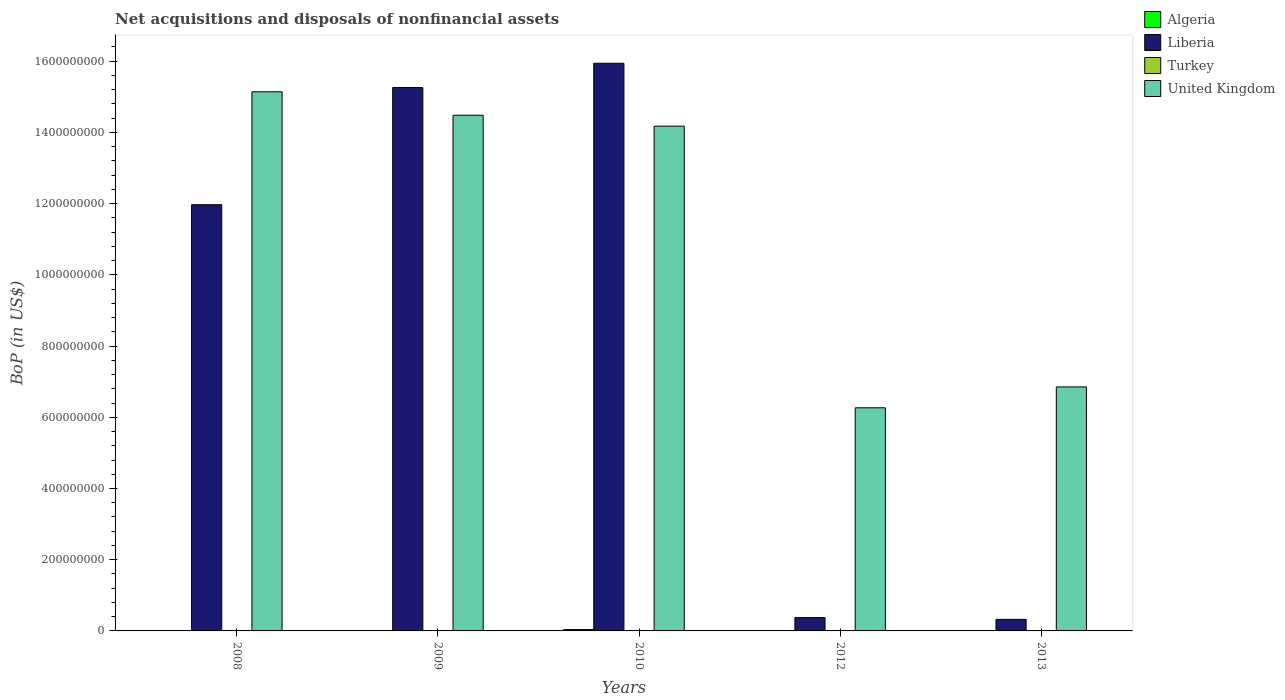How many groups of bars are there?
Offer a very short reply. 5. Are the number of bars on each tick of the X-axis equal?
Provide a succinct answer. No. How many bars are there on the 1st tick from the left?
Ensure brevity in your answer.  2. How many bars are there on the 2nd tick from the right?
Make the answer very short. 2. In how many cases, is the number of bars for a given year not equal to the number of legend labels?
Your answer should be compact. 5. What is the Balance of Payments in Liberia in 2012?
Ensure brevity in your answer.  3.74e+07. Across all years, what is the maximum Balance of Payments in United Kingdom?
Your response must be concise. 1.51e+09. Across all years, what is the minimum Balance of Payments in Turkey?
Make the answer very short. 0. What is the total Balance of Payments in Algeria in the graph?
Ensure brevity in your answer.  4.05e+06. What is the difference between the Balance of Payments in United Kingdom in 2010 and that in 2013?
Your answer should be very brief. 7.32e+08. What is the difference between the Balance of Payments in Liberia in 2008 and the Balance of Payments in United Kingdom in 2010?
Provide a short and direct response. -2.21e+08. What is the average Balance of Payments in United Kingdom per year?
Your answer should be very brief. 1.14e+09. In the year 2010, what is the difference between the Balance of Payments in Algeria and Balance of Payments in United Kingdom?
Your answer should be very brief. -1.41e+09. In how many years, is the Balance of Payments in Liberia greater than 800000000 US$?
Ensure brevity in your answer.  3. What is the ratio of the Balance of Payments in United Kingdom in 2010 to that in 2013?
Offer a terse response. 2.07. Is the Balance of Payments in Liberia in 2008 less than that in 2010?
Make the answer very short. Yes. What is the difference between the highest and the second highest Balance of Payments in Liberia?
Your answer should be compact. 6.83e+07. What is the difference between the highest and the lowest Balance of Payments in United Kingdom?
Provide a succinct answer. 8.87e+08. Is the sum of the Balance of Payments in Liberia in 2009 and 2013 greater than the maximum Balance of Payments in Turkey across all years?
Give a very brief answer. Yes. Is it the case that in every year, the sum of the Balance of Payments in Turkey and Balance of Payments in Algeria is greater than the Balance of Payments in Liberia?
Provide a succinct answer. No. Are all the bars in the graph horizontal?
Give a very brief answer. No. How many years are there in the graph?
Give a very brief answer. 5. What is the difference between two consecutive major ticks on the Y-axis?
Offer a terse response. 2.00e+08. Does the graph contain any zero values?
Your answer should be very brief. Yes. How are the legend labels stacked?
Offer a very short reply. Vertical. What is the title of the graph?
Keep it short and to the point. Net acquisitions and disposals of nonfinancial assets. What is the label or title of the X-axis?
Provide a succinct answer. Years. What is the label or title of the Y-axis?
Your response must be concise. BoP (in US$). What is the BoP (in US$) of Liberia in 2008?
Offer a terse response. 1.20e+09. What is the BoP (in US$) of United Kingdom in 2008?
Provide a short and direct response. 1.51e+09. What is the BoP (in US$) in Liberia in 2009?
Ensure brevity in your answer.  1.53e+09. What is the BoP (in US$) of United Kingdom in 2009?
Offer a terse response. 1.45e+09. What is the BoP (in US$) in Algeria in 2010?
Provide a short and direct response. 3.82e+06. What is the BoP (in US$) in Liberia in 2010?
Offer a very short reply. 1.59e+09. What is the BoP (in US$) of Turkey in 2010?
Your answer should be very brief. 0. What is the BoP (in US$) in United Kingdom in 2010?
Your answer should be compact. 1.42e+09. What is the BoP (in US$) of Algeria in 2012?
Your answer should be very brief. 0. What is the BoP (in US$) in Liberia in 2012?
Your response must be concise. 3.74e+07. What is the BoP (in US$) in Turkey in 2012?
Your response must be concise. 0. What is the BoP (in US$) of United Kingdom in 2012?
Provide a short and direct response. 6.27e+08. What is the BoP (in US$) in Algeria in 2013?
Give a very brief answer. 2.24e+05. What is the BoP (in US$) of Liberia in 2013?
Give a very brief answer. 3.25e+07. What is the BoP (in US$) in United Kingdom in 2013?
Keep it short and to the point. 6.85e+08. Across all years, what is the maximum BoP (in US$) of Algeria?
Provide a short and direct response. 3.82e+06. Across all years, what is the maximum BoP (in US$) in Liberia?
Provide a succinct answer. 1.59e+09. Across all years, what is the maximum BoP (in US$) in United Kingdom?
Offer a very short reply. 1.51e+09. Across all years, what is the minimum BoP (in US$) in Liberia?
Offer a very short reply. 3.25e+07. Across all years, what is the minimum BoP (in US$) of United Kingdom?
Keep it short and to the point. 6.27e+08. What is the total BoP (in US$) of Algeria in the graph?
Give a very brief answer. 4.05e+06. What is the total BoP (in US$) in Liberia in the graph?
Your response must be concise. 4.39e+09. What is the total BoP (in US$) of United Kingdom in the graph?
Offer a very short reply. 5.69e+09. What is the difference between the BoP (in US$) of Liberia in 2008 and that in 2009?
Your answer should be compact. -3.29e+08. What is the difference between the BoP (in US$) of United Kingdom in 2008 and that in 2009?
Provide a succinct answer. 6.58e+07. What is the difference between the BoP (in US$) of Liberia in 2008 and that in 2010?
Provide a succinct answer. -3.97e+08. What is the difference between the BoP (in US$) of United Kingdom in 2008 and that in 2010?
Ensure brevity in your answer.  9.65e+07. What is the difference between the BoP (in US$) of Liberia in 2008 and that in 2012?
Offer a terse response. 1.16e+09. What is the difference between the BoP (in US$) in United Kingdom in 2008 and that in 2012?
Your answer should be compact. 8.87e+08. What is the difference between the BoP (in US$) of Liberia in 2008 and that in 2013?
Offer a very short reply. 1.16e+09. What is the difference between the BoP (in US$) of United Kingdom in 2008 and that in 2013?
Offer a very short reply. 8.29e+08. What is the difference between the BoP (in US$) of Liberia in 2009 and that in 2010?
Provide a succinct answer. -6.83e+07. What is the difference between the BoP (in US$) in United Kingdom in 2009 and that in 2010?
Keep it short and to the point. 3.08e+07. What is the difference between the BoP (in US$) of Liberia in 2009 and that in 2012?
Ensure brevity in your answer.  1.49e+09. What is the difference between the BoP (in US$) in United Kingdom in 2009 and that in 2012?
Provide a short and direct response. 8.22e+08. What is the difference between the BoP (in US$) of Liberia in 2009 and that in 2013?
Your response must be concise. 1.49e+09. What is the difference between the BoP (in US$) in United Kingdom in 2009 and that in 2013?
Your answer should be very brief. 7.63e+08. What is the difference between the BoP (in US$) in Liberia in 2010 and that in 2012?
Ensure brevity in your answer.  1.56e+09. What is the difference between the BoP (in US$) in United Kingdom in 2010 and that in 2012?
Offer a terse response. 7.91e+08. What is the difference between the BoP (in US$) of Algeria in 2010 and that in 2013?
Ensure brevity in your answer.  3.60e+06. What is the difference between the BoP (in US$) in Liberia in 2010 and that in 2013?
Your answer should be very brief. 1.56e+09. What is the difference between the BoP (in US$) of United Kingdom in 2010 and that in 2013?
Your answer should be compact. 7.32e+08. What is the difference between the BoP (in US$) in Liberia in 2012 and that in 2013?
Offer a terse response. 4.90e+06. What is the difference between the BoP (in US$) of United Kingdom in 2012 and that in 2013?
Make the answer very short. -5.86e+07. What is the difference between the BoP (in US$) in Liberia in 2008 and the BoP (in US$) in United Kingdom in 2009?
Provide a short and direct response. -2.51e+08. What is the difference between the BoP (in US$) in Liberia in 2008 and the BoP (in US$) in United Kingdom in 2010?
Provide a short and direct response. -2.21e+08. What is the difference between the BoP (in US$) in Liberia in 2008 and the BoP (in US$) in United Kingdom in 2012?
Provide a succinct answer. 5.70e+08. What is the difference between the BoP (in US$) in Liberia in 2008 and the BoP (in US$) in United Kingdom in 2013?
Offer a very short reply. 5.12e+08. What is the difference between the BoP (in US$) of Liberia in 2009 and the BoP (in US$) of United Kingdom in 2010?
Ensure brevity in your answer.  1.08e+08. What is the difference between the BoP (in US$) of Liberia in 2009 and the BoP (in US$) of United Kingdom in 2012?
Ensure brevity in your answer.  8.99e+08. What is the difference between the BoP (in US$) of Liberia in 2009 and the BoP (in US$) of United Kingdom in 2013?
Provide a short and direct response. 8.41e+08. What is the difference between the BoP (in US$) in Algeria in 2010 and the BoP (in US$) in Liberia in 2012?
Offer a very short reply. -3.36e+07. What is the difference between the BoP (in US$) of Algeria in 2010 and the BoP (in US$) of United Kingdom in 2012?
Provide a short and direct response. -6.23e+08. What is the difference between the BoP (in US$) of Liberia in 2010 and the BoP (in US$) of United Kingdom in 2012?
Your answer should be compact. 9.68e+08. What is the difference between the BoP (in US$) of Algeria in 2010 and the BoP (in US$) of Liberia in 2013?
Your response must be concise. -2.87e+07. What is the difference between the BoP (in US$) in Algeria in 2010 and the BoP (in US$) in United Kingdom in 2013?
Give a very brief answer. -6.81e+08. What is the difference between the BoP (in US$) of Liberia in 2010 and the BoP (in US$) of United Kingdom in 2013?
Give a very brief answer. 9.09e+08. What is the difference between the BoP (in US$) in Liberia in 2012 and the BoP (in US$) in United Kingdom in 2013?
Offer a terse response. -6.48e+08. What is the average BoP (in US$) of Algeria per year?
Your response must be concise. 8.09e+05. What is the average BoP (in US$) of Liberia per year?
Your response must be concise. 8.77e+08. What is the average BoP (in US$) of United Kingdom per year?
Your answer should be very brief. 1.14e+09. In the year 2008, what is the difference between the BoP (in US$) in Liberia and BoP (in US$) in United Kingdom?
Make the answer very short. -3.17e+08. In the year 2009, what is the difference between the BoP (in US$) of Liberia and BoP (in US$) of United Kingdom?
Your response must be concise. 7.77e+07. In the year 2010, what is the difference between the BoP (in US$) of Algeria and BoP (in US$) of Liberia?
Provide a succinct answer. -1.59e+09. In the year 2010, what is the difference between the BoP (in US$) of Algeria and BoP (in US$) of United Kingdom?
Make the answer very short. -1.41e+09. In the year 2010, what is the difference between the BoP (in US$) of Liberia and BoP (in US$) of United Kingdom?
Your answer should be very brief. 1.77e+08. In the year 2012, what is the difference between the BoP (in US$) of Liberia and BoP (in US$) of United Kingdom?
Your response must be concise. -5.89e+08. In the year 2013, what is the difference between the BoP (in US$) of Algeria and BoP (in US$) of Liberia?
Your response must be concise. -3.23e+07. In the year 2013, what is the difference between the BoP (in US$) of Algeria and BoP (in US$) of United Kingdom?
Your response must be concise. -6.85e+08. In the year 2013, what is the difference between the BoP (in US$) of Liberia and BoP (in US$) of United Kingdom?
Offer a very short reply. -6.53e+08. What is the ratio of the BoP (in US$) of Liberia in 2008 to that in 2009?
Your answer should be very brief. 0.78. What is the ratio of the BoP (in US$) of United Kingdom in 2008 to that in 2009?
Make the answer very short. 1.05. What is the ratio of the BoP (in US$) in Liberia in 2008 to that in 2010?
Provide a short and direct response. 0.75. What is the ratio of the BoP (in US$) of United Kingdom in 2008 to that in 2010?
Ensure brevity in your answer.  1.07. What is the ratio of the BoP (in US$) in Liberia in 2008 to that in 2012?
Offer a very short reply. 32. What is the ratio of the BoP (in US$) in United Kingdom in 2008 to that in 2012?
Provide a succinct answer. 2.42. What is the ratio of the BoP (in US$) in Liberia in 2008 to that in 2013?
Keep it short and to the point. 36.82. What is the ratio of the BoP (in US$) of United Kingdom in 2008 to that in 2013?
Provide a succinct answer. 2.21. What is the ratio of the BoP (in US$) of Liberia in 2009 to that in 2010?
Make the answer very short. 0.96. What is the ratio of the BoP (in US$) of United Kingdom in 2009 to that in 2010?
Provide a short and direct response. 1.02. What is the ratio of the BoP (in US$) of Liberia in 2009 to that in 2012?
Give a very brief answer. 40.8. What is the ratio of the BoP (in US$) in United Kingdom in 2009 to that in 2012?
Keep it short and to the point. 2.31. What is the ratio of the BoP (in US$) of Liberia in 2009 to that in 2013?
Provide a short and direct response. 46.94. What is the ratio of the BoP (in US$) of United Kingdom in 2009 to that in 2013?
Provide a succinct answer. 2.11. What is the ratio of the BoP (in US$) of Liberia in 2010 to that in 2012?
Ensure brevity in your answer.  42.62. What is the ratio of the BoP (in US$) of United Kingdom in 2010 to that in 2012?
Offer a terse response. 2.26. What is the ratio of the BoP (in US$) of Algeria in 2010 to that in 2013?
Ensure brevity in your answer.  17.08. What is the ratio of the BoP (in US$) of Liberia in 2010 to that in 2013?
Give a very brief answer. 49.04. What is the ratio of the BoP (in US$) in United Kingdom in 2010 to that in 2013?
Offer a very short reply. 2.07. What is the ratio of the BoP (in US$) of Liberia in 2012 to that in 2013?
Provide a succinct answer. 1.15. What is the ratio of the BoP (in US$) of United Kingdom in 2012 to that in 2013?
Your response must be concise. 0.91. What is the difference between the highest and the second highest BoP (in US$) in Liberia?
Offer a very short reply. 6.83e+07. What is the difference between the highest and the second highest BoP (in US$) of United Kingdom?
Provide a succinct answer. 6.58e+07. What is the difference between the highest and the lowest BoP (in US$) in Algeria?
Provide a succinct answer. 3.82e+06. What is the difference between the highest and the lowest BoP (in US$) of Liberia?
Your response must be concise. 1.56e+09. What is the difference between the highest and the lowest BoP (in US$) in United Kingdom?
Your answer should be compact. 8.87e+08. 